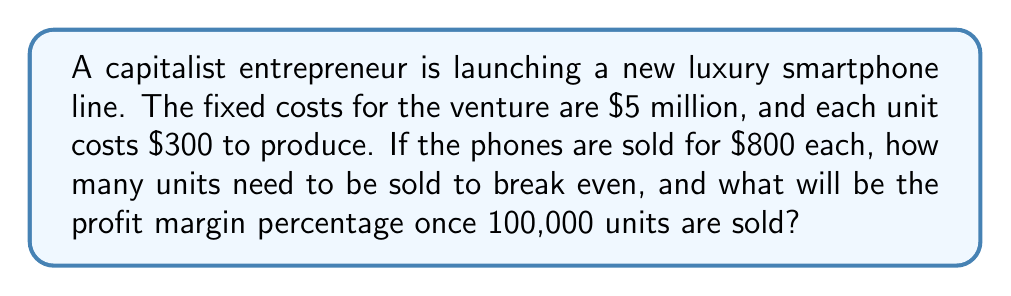Teach me how to tackle this problem. Let's approach this step-by-step:

1. Calculate the break-even point:
   Let $x$ be the number of units sold.
   Revenue = Price per unit × Number of units
   $$ \text{Revenue} = 800x $$
   Total Cost = Fixed Costs + (Variable Cost per unit × Number of units)
   $$ \text{Total Cost} = 5,000,000 + 300x $$
   At break-even point, Revenue = Total Cost
   $$ 800x = 5,000,000 + 300x $$
   $$ 500x = 5,000,000 $$
   $$ x = 10,000 \text{ units} $$

2. Calculate profit at 100,000 units:
   Revenue at 100,000 units: $$ 800 \times 100,000 = 80,000,000 $$
   Total Cost at 100,000 units: $$ 5,000,000 + (300 \times 100,000) = 35,000,000 $$
   Profit: $$ 80,000,000 - 35,000,000 = 45,000,000 $$

3. Calculate profit margin percentage:
   $$ \text{Profit Margin} = \frac{\text{Profit}}{\text{Revenue}} \times 100\% $$
   $$ = \frac{45,000,000}{80,000,000} \times 100\% = 56.25\% $$
Answer: 10,000 units to break even; 56.25% profit margin at 100,000 units 